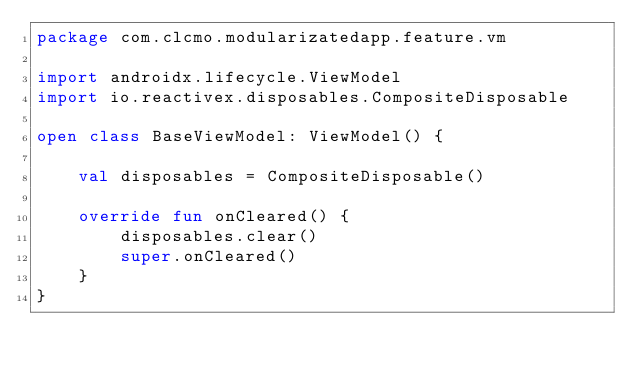Convert code to text. <code><loc_0><loc_0><loc_500><loc_500><_Kotlin_>package com.clcmo.modularizatedapp.feature.vm

import androidx.lifecycle.ViewModel
import io.reactivex.disposables.CompositeDisposable

open class BaseViewModel: ViewModel() {

    val disposables = CompositeDisposable()

    override fun onCleared() {
        disposables.clear()
        super.onCleared()
    }
}</code> 